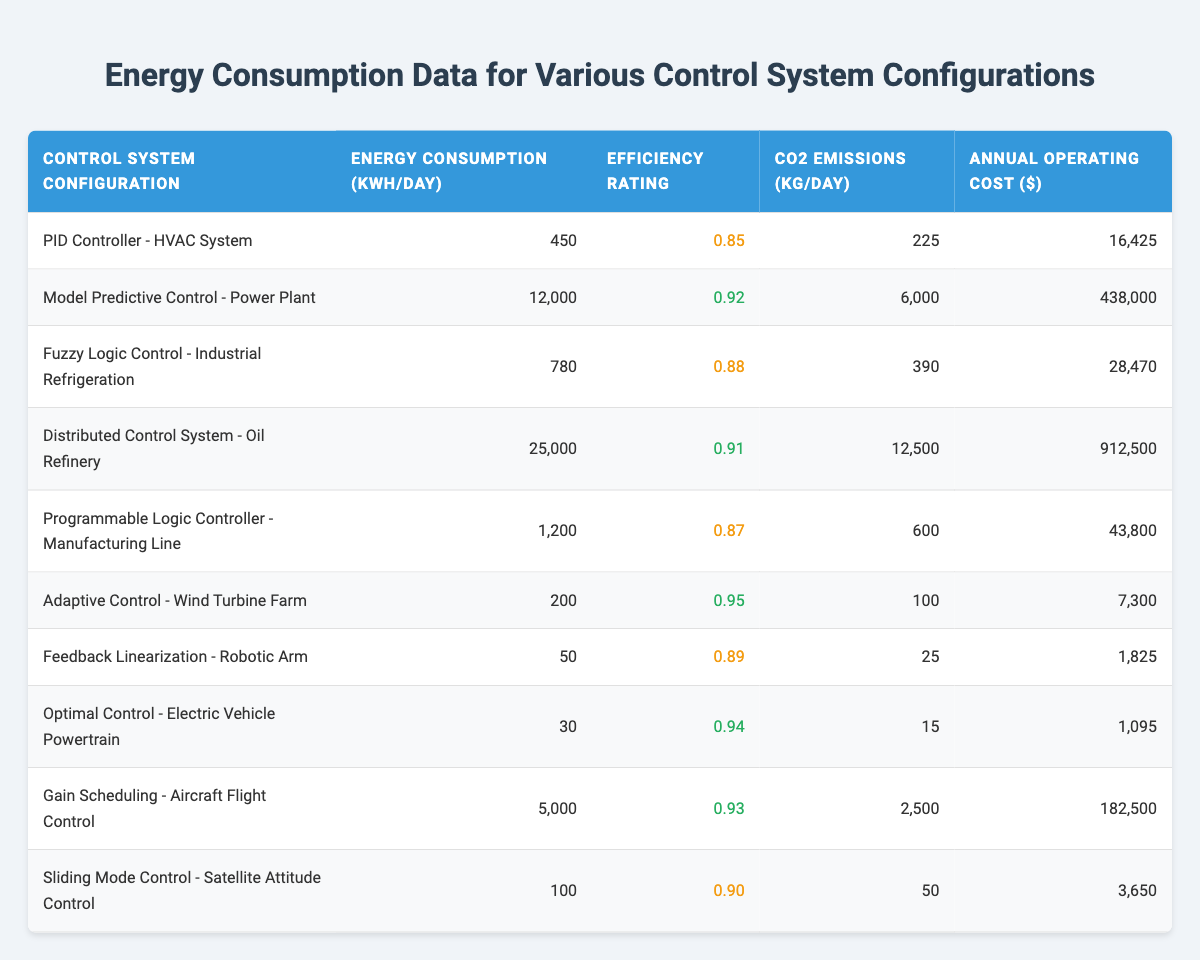What is the energy consumption of the Distributed Control System - Oil Refinery? The table lists the energy consumption values for each control system configuration. For the Distributed Control System - Oil Refinery, the value is found directly in the second column.
Answer: 25000 Which control system has the highest CO2 emissions? By examining the CO2 emissions column, the Distributed Control System - Oil Refinery shows the highest value at 12500 kg/day. This is higher than all other configurations listed.
Answer: Distributed Control System - Oil Refinery What is the efficiency rating of the Adaptive Control - Wind Turbine Farm? The efficiency rating for the Adaptive Control - Wind Turbine Farm can be found in the third column. It is clearly stated that the rating is 0.95.
Answer: 0.95 What is the total annual operating cost of the PID Controller - HVAC System and the Programmable Logic Controller - Manufacturing Line? We first identify the annual operating costs from the last column. For the PID Controller - HVAC System, the cost is 16425 dollars, and for the Programmable Logic Controller - Manufacturing Line, it is 43800 dollars. By adding both values together: 16425 + 43800 = 60225 dollars.
Answer: 60225 Is the Model Predictive Control - Power Plant more efficient than the Gain Scheduling - Aircraft Flight Control? From the efficiency ratings column, the Model Predictive Control - Power Plant has a rating of 0.92, while the Gain Scheduling - Aircraft Flight Control has a rating of 0.93. Since 0.93 is greater than 0.92, the Gain Scheduling configuration is indeed more efficient.
Answer: No Which control system configurations have energy consumption below 1000 kWh/day? We review the energy consumption column and find the following configurations with values below 1000 kWh/day: Feedback Linearization - Robotic Arm (50 kWh/day), Optimal Control - Electric Vehicle Powertrain (30 kWh/day), and Adaptive Control - Wind Turbine Farm (200 kWh/day). Thus, these three configurations meet the criteria of having values less than 1000 kWh/day.
Answer: Feedback Linearization - Robotic Arm, Optimal Control - Electric Vehicle Powertrain, Adaptive Control - Wind Turbine Farm What is the average energy consumption of all listed control systems? To calculate the average, we sum all energy consumption values from the second column: 450 + 12000 + 780 + 25000 + 1200 + 200 + 50 + 30 + 5000 + 100 = 31810 kWh/day. Then, since there are 10 configurations, we compute the average: 31810 / 10 = 3181 kWh/day.
Answer: 3181 Is the Fuzzy Logic Control - Industrial Refrigeration's energy consumption greater than the sum of the energy consumption of the PID Controller - HVAC System and Sliding Mode Control - Satellite Attitude Control? The energy consumption of the Fuzzy Logic Control - Industrial Refrigeration is 780 kWh/day. The PID Controller - HVAC System has 450 kWh/day and the Sliding Mode Control - Satellite Attitude Control has 100 kWh/day. Summing these gives us: 450 + 100 = 550 kWh/day. Since 780 kWh/day is greater than 550 kWh/day, the answer is yes.
Answer: Yes 